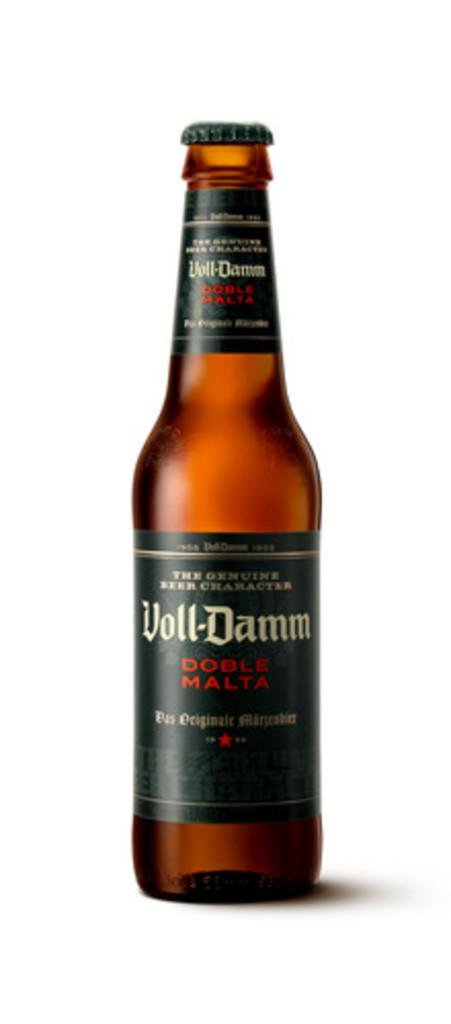What object can be seen in the image? There is a bottle in the image. What feature is present on the bottle? The bottle has labels on it. What information can be found on the labels? There is writing on the labels. How does the skate help the person in the image? There is no skate present in the image, so it cannot help anyone in the design. 